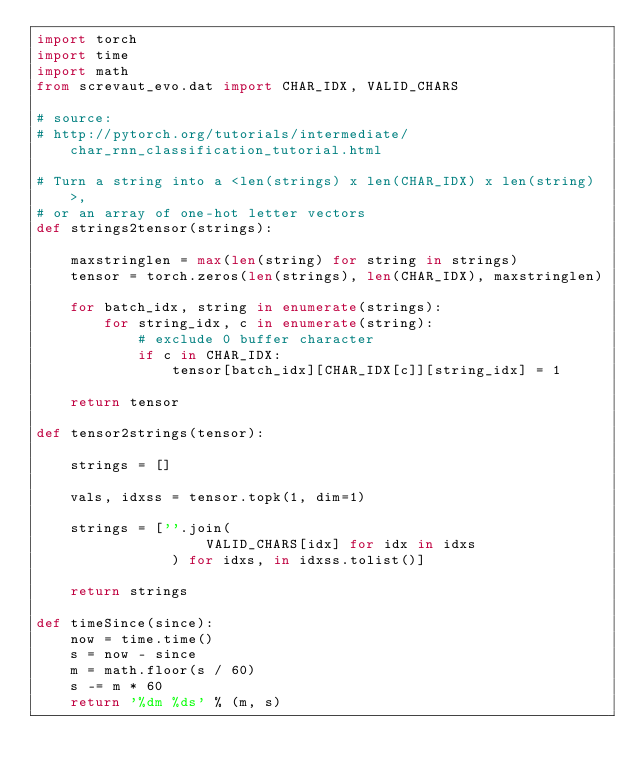<code> <loc_0><loc_0><loc_500><loc_500><_Python_>import torch
import time
import math
from screvaut_evo.dat import CHAR_IDX, VALID_CHARS

# source:
# http://pytorch.org/tutorials/intermediate/char_rnn_classification_tutorial.html

# Turn a string into a <len(strings) x len(CHAR_IDX) x len(string)>,
# or an array of one-hot letter vectors
def strings2tensor(strings):

    maxstringlen = max(len(string) for string in strings)
    tensor = torch.zeros(len(strings), len(CHAR_IDX), maxstringlen)

    for batch_idx, string in enumerate(strings):
        for string_idx, c in enumerate(string):
            # exclude 0 buffer character
            if c in CHAR_IDX:
                tensor[batch_idx][CHAR_IDX[c]][string_idx] = 1

    return tensor

def tensor2strings(tensor):

    strings = []

    vals, idxss = tensor.topk(1, dim=1)

    strings = [''.join(
                    VALID_CHARS[idx] for idx in idxs
                ) for idxs, in idxss.tolist()]

    return strings

def timeSince(since):
    now = time.time()
    s = now - since
    m = math.floor(s / 60)
    s -= m * 60
    return '%dm %ds' % (m, s)
</code> 